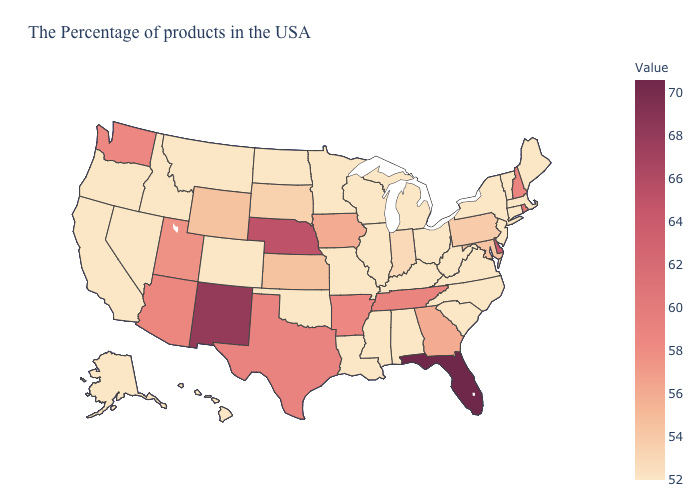Does Idaho have the lowest value in the West?
Write a very short answer. Yes. Which states have the lowest value in the West?
Keep it brief. Colorado, Montana, Idaho, Nevada, California, Oregon, Alaska, Hawaii. Which states have the highest value in the USA?
Quick response, please. Florida. Does New Hampshire have a lower value than Missouri?
Answer briefly. No. Which states have the highest value in the USA?
Write a very short answer. Florida. 